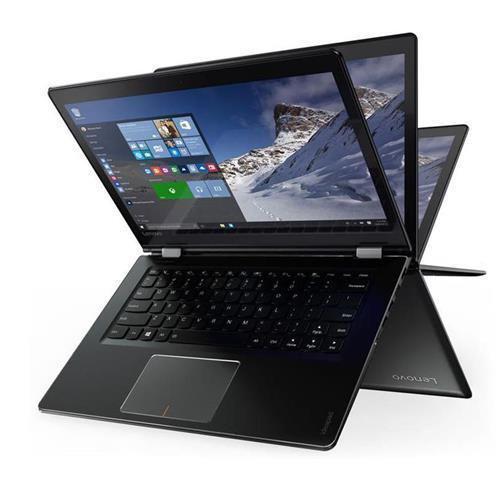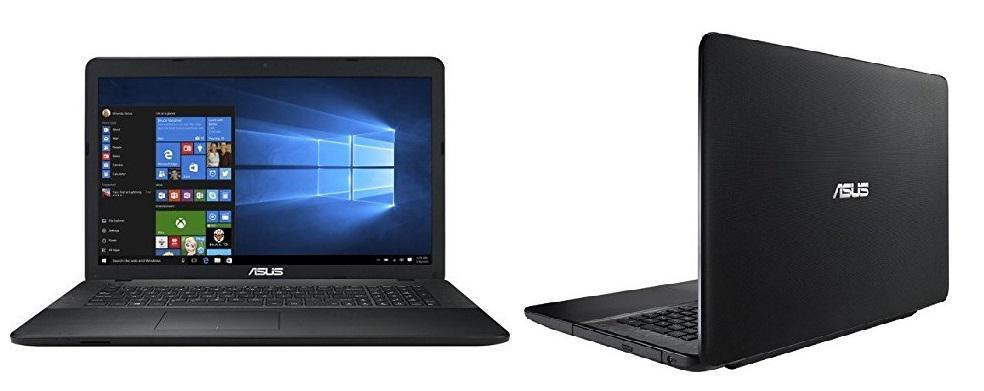The first image is the image on the left, the second image is the image on the right. For the images shown, is this caption "The right image contains exactly four laptop computers." true? Answer yes or no. No. The first image is the image on the left, the second image is the image on the right. Assess this claim about the two images: "There are more devices in the image on the left than in the image on the right.". Correct or not? Answer yes or no. No. 